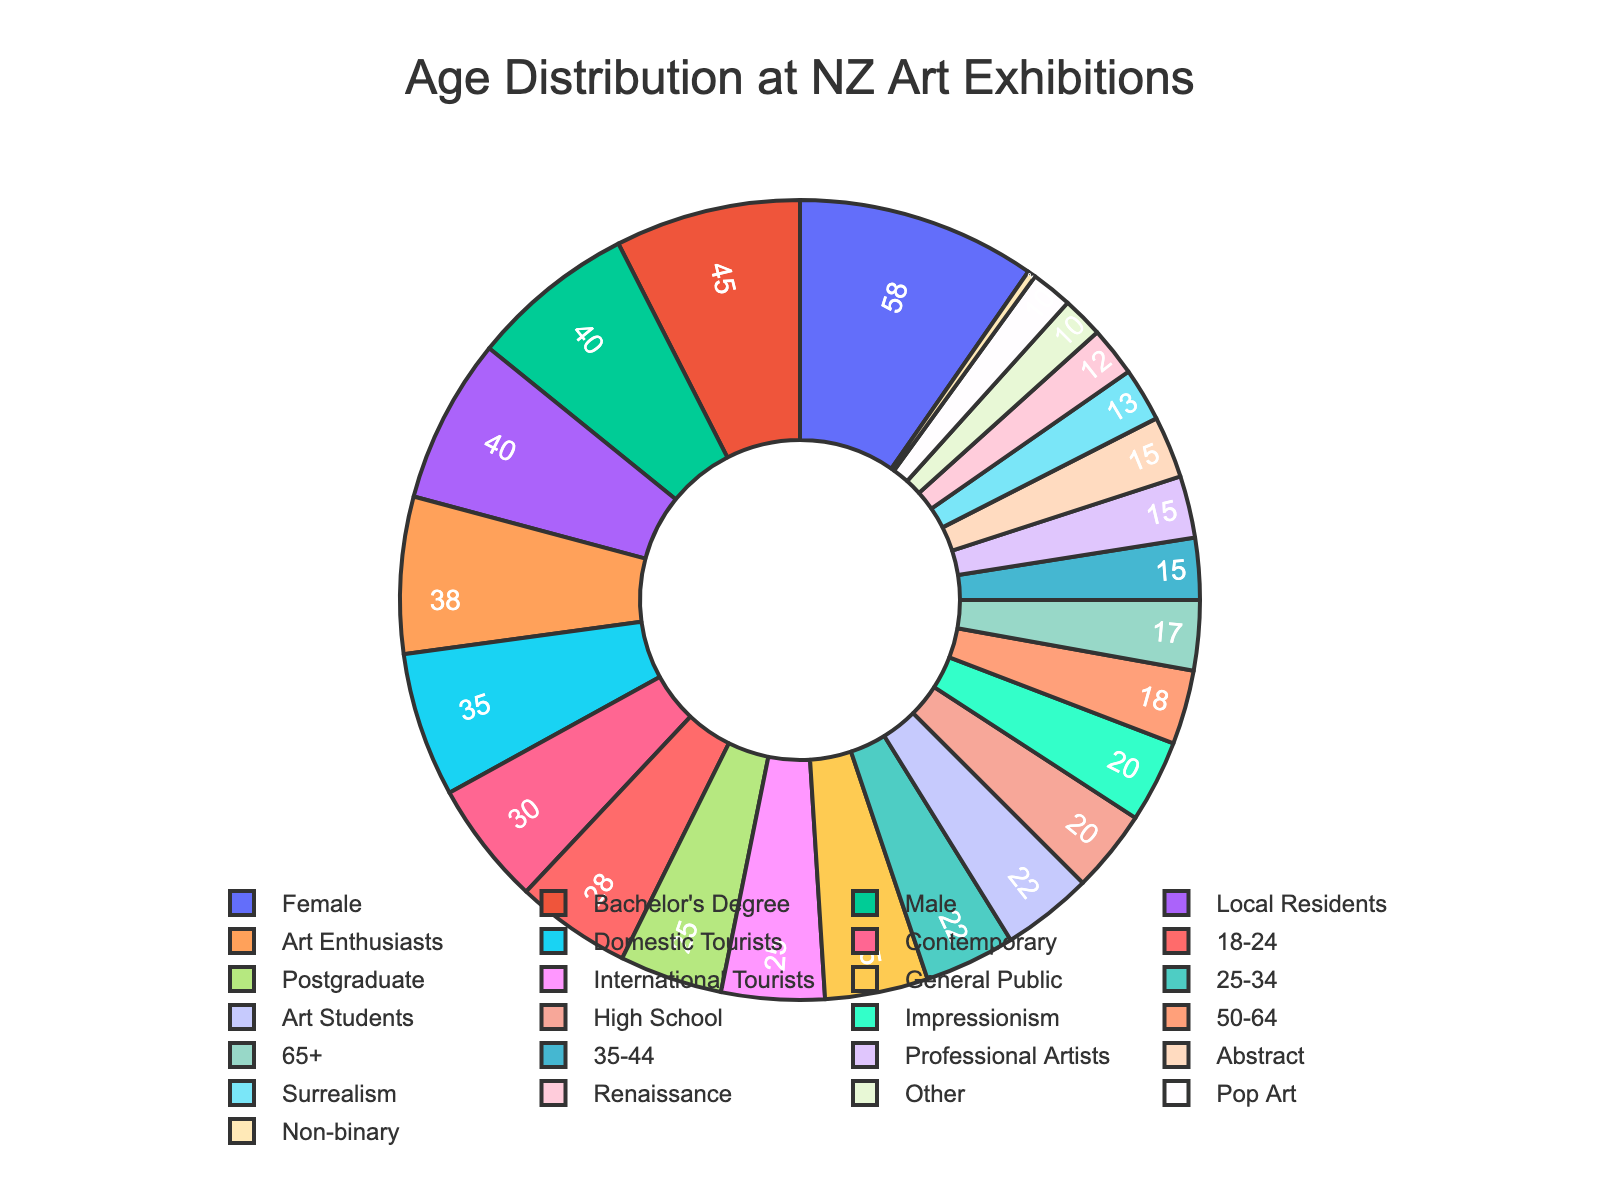Which age group has the largest percentage of visitors? The slice with the label "18-24" is the largest, indicating that this age group has the largest percentage.
Answer: 18-24 What's the combined percentage of visitors aged 50 and above? Add the percentages of the 50-64 and 65+ age groups: 18% + 17% = 35%.
Answer: 35% How much greater is the percentage of 18-24 visitors compared to 35-44 visitors? Subtract the percentage of the 35-44 age group from the 18-24 age group: 28% - 15% = 13%.
Answer: 13% Which age group has the smallest slice in the pie chart? The smallest slice corresponds to the "35-44" age group with 15%.
Answer: 35-44 Compare the percentage of visitors aged 18-24 to those aged 65+. Which group has more visitors and by how much? The 18-24 age group has 28% while the 65+ age group has 17%. 28% - 17% = 11%.
Answer: 18-24 by 11% What is the average percentage of visitors aged under 35? Combine the percentages of the 18-24 and 25-34 age groups and divide by 2: (28% + 22%) / 2 = 25%.
Answer: 25% Which age groups have a percentage difference that is exactly 3%? Compare each pair: 25-34 and 50-64 both have a difference of 3% (22% - 18% = 4%, but looking closer, 22% and 25-34 have a 3% difference).
Answer: 25-34 and 50-64 What's the percentage of visitors who are younger than 35 years old? Add the percentages of the 18-24 and 25-34 age groups: 28% + 22% = 50%.
Answer: 50% Which age group forms approximately one-fifth of the visitor demographic? The age group with a percentage close to 20% is the 25-34 group with 22%.
Answer: 25-34 